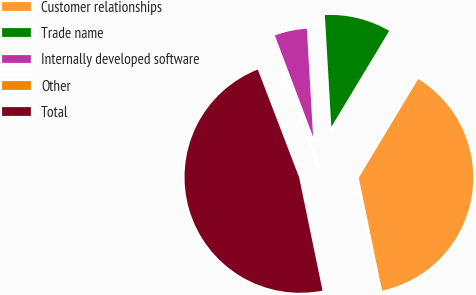<chart> <loc_0><loc_0><loc_500><loc_500><pie_chart><fcel>Customer relationships<fcel>Trade name<fcel>Internally developed software<fcel>Other<fcel>Total<nl><fcel>38.13%<fcel>9.55%<fcel>4.82%<fcel>0.08%<fcel>47.42%<nl></chart> 